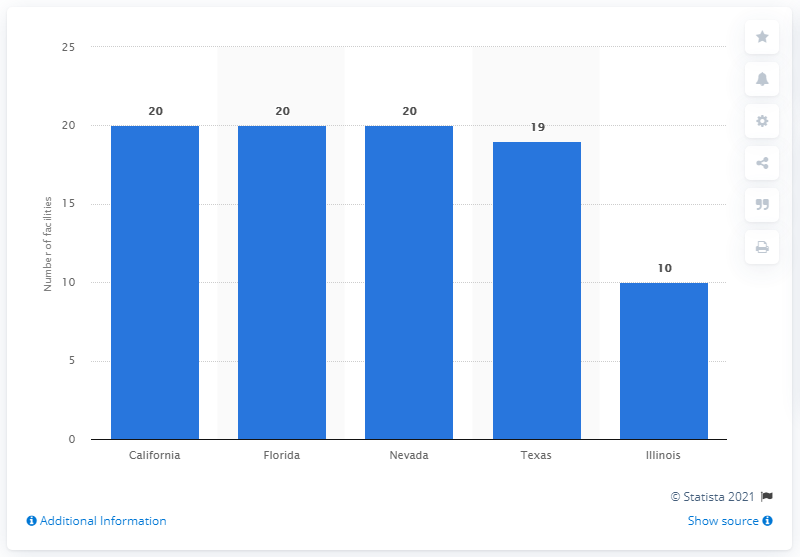Give some essential details in this illustration. In California, Florida, and Nevada, there were a total of 20 convention centers. 